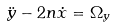Convert formula to latex. <formula><loc_0><loc_0><loc_500><loc_500>\ddot { y } - 2 n \dot { x } = \Omega _ { y }</formula> 